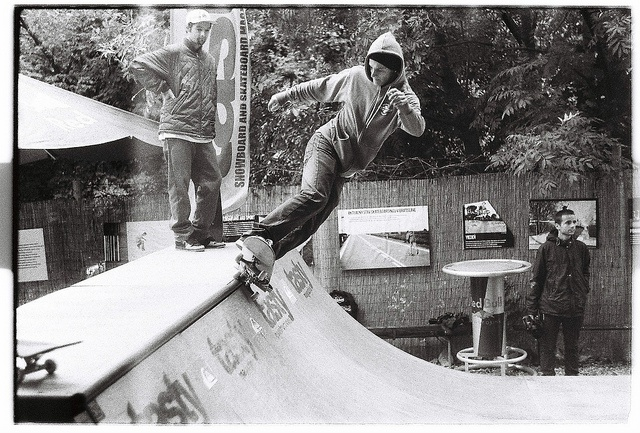Describe the objects in this image and their specific colors. I can see people in white, black, gray, darkgray, and lightgray tones, people in white, gray, darkgray, lightgray, and black tones, people in white, black, gray, and darkgray tones, skateboard in white, darkgray, gray, black, and lightgray tones, and skateboard in white, black, gray, and darkgray tones in this image. 